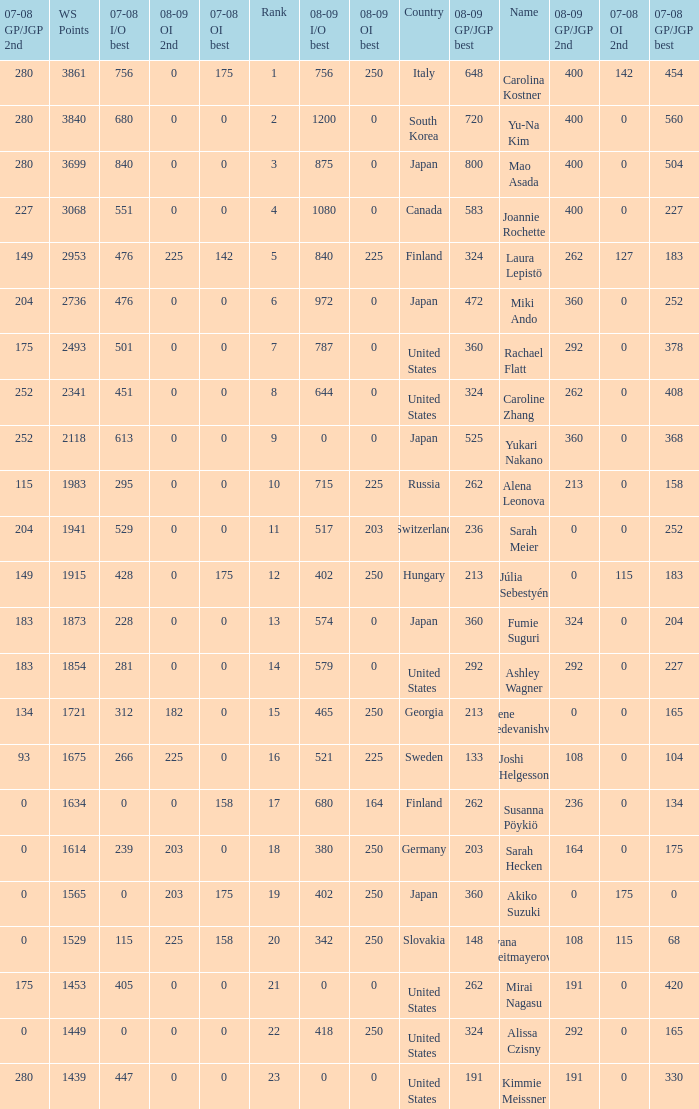Parse the table in full. {'header': ['07-08 GP/JGP 2nd', 'WS Points', '07-08 I/O best', '08-09 OI 2nd', '07-08 OI best', 'Rank', '08-09 I/O best', '08-09 OI best', 'Country', '08-09 GP/JGP best', 'Name', '08-09 GP/JGP 2nd', '07-08 OI 2nd', '07-08 GP/JGP best'], 'rows': [['280', '3861', '756', '0', '175', '1', '756', '250', 'Italy', '648', 'Carolina Kostner', '400', '142', '454'], ['280', '3840', '680', '0', '0', '2', '1200', '0', 'South Korea', '720', 'Yu-Na Kim', '400', '0', '560'], ['280', '3699', '840', '0', '0', '3', '875', '0', 'Japan', '800', 'Mao Asada', '400', '0', '504'], ['227', '3068', '551', '0', '0', '4', '1080', '0', 'Canada', '583', 'Joannie Rochette', '400', '0', '227'], ['149', '2953', '476', '225', '142', '5', '840', '225', 'Finland', '324', 'Laura Lepistö', '262', '127', '183'], ['204', '2736', '476', '0', '0', '6', '972', '0', 'Japan', '472', 'Miki Ando', '360', '0', '252'], ['175', '2493', '501', '0', '0', '7', '787', '0', 'United States', '360', 'Rachael Flatt', '292', '0', '378'], ['252', '2341', '451', '0', '0', '8', '644', '0', 'United States', '324', 'Caroline Zhang', '262', '0', '408'], ['252', '2118', '613', '0', '0', '9', '0', '0', 'Japan', '525', 'Yukari Nakano', '360', '0', '368'], ['115', '1983', '295', '0', '0', '10', '715', '225', 'Russia', '262', 'Alena Leonova', '213', '0', '158'], ['204', '1941', '529', '0', '0', '11', '517', '203', 'Switzerland', '236', 'Sarah Meier', '0', '0', '252'], ['149', '1915', '428', '0', '175', '12', '402', '250', 'Hungary', '213', 'Júlia Sebestyén', '0', '115', '183'], ['183', '1873', '228', '0', '0', '13', '574', '0', 'Japan', '360', 'Fumie Suguri', '324', '0', '204'], ['183', '1854', '281', '0', '0', '14', '579', '0', 'United States', '292', 'Ashley Wagner', '292', '0', '227'], ['134', '1721', '312', '182', '0', '15', '465', '250', 'Georgia', '213', 'Elene Gedevanishvili', '0', '0', '165'], ['93', '1675', '266', '225', '0', '16', '521', '225', 'Sweden', '133', 'Joshi Helgesson', '108', '0', '104'], ['0', '1634', '0', '0', '158', '17', '680', '164', 'Finland', '262', 'Susanna Pöykiö', '236', '0', '134'], ['0', '1614', '239', '203', '0', '18', '380', '250', 'Germany', '203', 'Sarah Hecken', '164', '0', '175'], ['0', '1565', '0', '203', '175', '19', '402', '250', 'Japan', '360', 'Akiko Suzuki', '0', '175', '0'], ['0', '1529', '115', '225', '158', '20', '342', '250', 'Slovakia', '148', 'Ivana Reitmayerova', '108', '115', '68'], ['175', '1453', '405', '0', '0', '21', '0', '0', 'United States', '262', 'Mirai Nagasu', '191', '0', '420'], ['0', '1449', '0', '0', '0', '22', '418', '250', 'United States', '324', 'Alissa Czisny', '292', '0', '165'], ['280', '1439', '447', '0', '0', '23', '0', '0', 'United States', '191', 'Kimmie Meissner', '191', '0', '330']]} 08-09 gp/jgp 2nd is 213 and ws points will be what maximum 1983.0. 